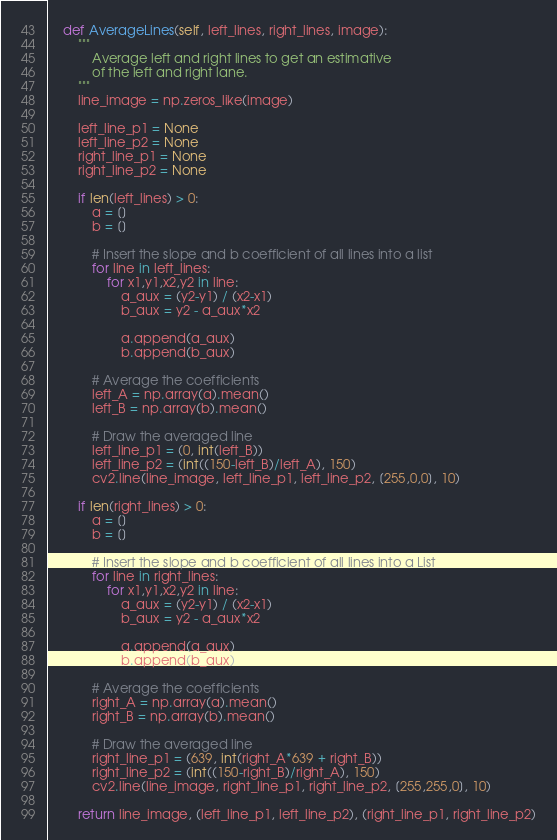<code> <loc_0><loc_0><loc_500><loc_500><_Python_>    def AverageLines(self, left_lines, right_lines, image):
        """
            Average left and right lines to get an estimative
            of the left and right lane.
        """
        line_image = np.zeros_like(image)
        
        left_line_p1 = None
        left_line_p2 = None
        right_line_p1 = None
        right_line_p2 = None

        if len(left_lines) > 0:
            a = []
            b = []

            # Insert the slope and b coefficient of all lines into a list
            for line in left_lines:
                for x1,y1,x2,y2 in line:
                    a_aux = (y2-y1) / (x2-x1)
                    b_aux = y2 - a_aux*x2

                    a.append(a_aux)
                    b.append(b_aux)

            # Average the coefficients
            left_A = np.array(a).mean()
            left_B = np.array(b).mean()

            # Draw the averaged line
            left_line_p1 = (0, int(left_B))
            left_line_p2 = (int((150-left_B)/left_A), 150)
            cv2.line(line_image, left_line_p1, left_line_p2, [255,0,0], 10)

        if len(right_lines) > 0:
            a = []
            b = []

            # Insert the slope and b coefficient of all lines into a List
            for line in right_lines:
                for x1,y1,x2,y2 in line:
                    a_aux = (y2-y1) / (x2-x1)
                    b_aux = y2 - a_aux*x2

                    a.append(a_aux)
                    b.append(b_aux)

            # Average the coefficients
            right_A = np.array(a).mean()
            right_B = np.array(b).mean()

            # Draw the averaged line
            right_line_p1 = (639, int(right_A*639 + right_B))
            right_line_p2 = (int((150-right_B)/right_A), 150)
            cv2.line(line_image, right_line_p1, right_line_p2, [255,255,0], 10)

        return line_image, (left_line_p1, left_line_p2), (right_line_p1, right_line_p2)</code> 